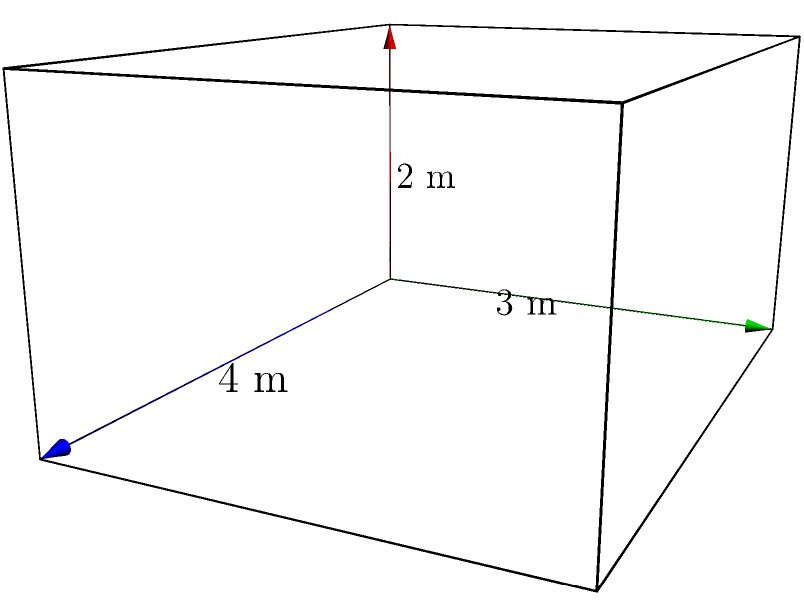As part of a school renovation project, you need to calculate the volume of a new storage room. The room is shaped like a rectangular prism with dimensions of 4 meters in length, 3 meters in width, and 2 meters in height. What is the volume of this storage room in cubic meters? To calculate the volume of a rectangular prism, we use the formula:

$$V = l \times w \times h$$

Where:
$V$ = volume
$l$ = length
$w$ = width
$h$ = height

Given dimensions:
Length ($l$) = 4 meters
Width ($w$) = 3 meters
Height ($h$) = 2 meters

Let's substitute these values into the formula:

$$V = 4 \text{ m} \times 3 \text{ m} \times 2 \text{ m}$$

Now, let's multiply:

$$V = 24 \text{ m}^3$$

Therefore, the volume of the storage room is 24 cubic meters.

Understanding this calculation is crucial for school administrators when planning space utilization, estimating storage capacity, or determining ventilation requirements for different areas within the school building.
Answer: $24 \text{ m}^3$ 